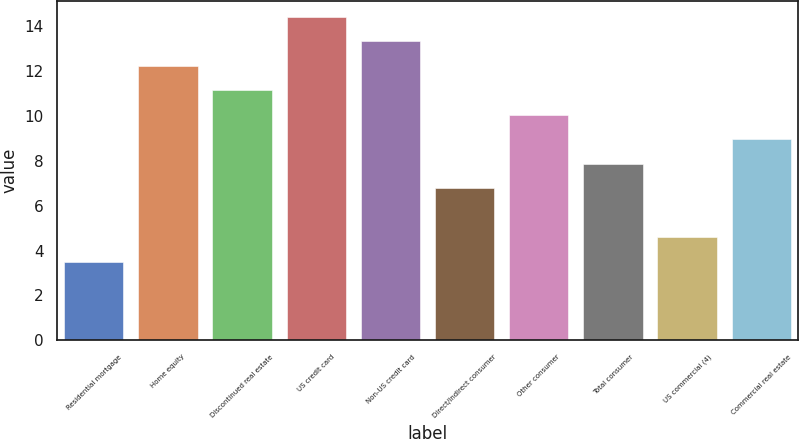<chart> <loc_0><loc_0><loc_500><loc_500><bar_chart><fcel>Residential mortgage<fcel>Home equity<fcel>Discontinued real estate<fcel>US credit card<fcel>Non-US credit card<fcel>Direct/Indirect consumer<fcel>Other consumer<fcel>Total consumer<fcel>US commercial (4)<fcel>Commercial real estate<nl><fcel>3.49<fcel>12.21<fcel>11.12<fcel>14.39<fcel>13.3<fcel>6.76<fcel>10.03<fcel>7.85<fcel>4.58<fcel>8.94<nl></chart> 